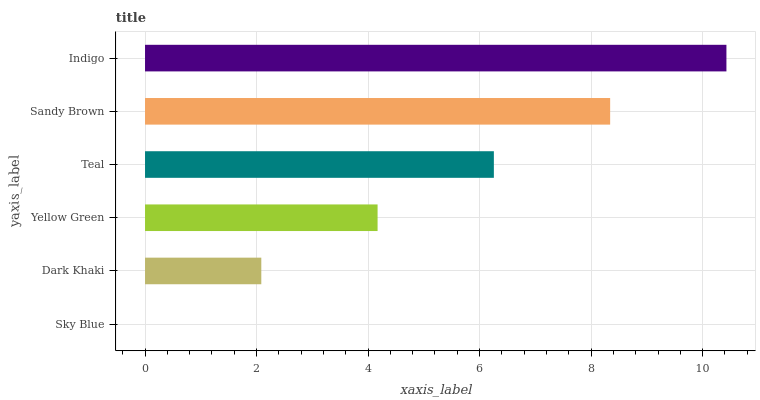Is Sky Blue the minimum?
Answer yes or no. Yes. Is Indigo the maximum?
Answer yes or no. Yes. Is Dark Khaki the minimum?
Answer yes or no. No. Is Dark Khaki the maximum?
Answer yes or no. No. Is Dark Khaki greater than Sky Blue?
Answer yes or no. Yes. Is Sky Blue less than Dark Khaki?
Answer yes or no. Yes. Is Sky Blue greater than Dark Khaki?
Answer yes or no. No. Is Dark Khaki less than Sky Blue?
Answer yes or no. No. Is Teal the high median?
Answer yes or no. Yes. Is Yellow Green the low median?
Answer yes or no. Yes. Is Sandy Brown the high median?
Answer yes or no. No. Is Dark Khaki the low median?
Answer yes or no. No. 